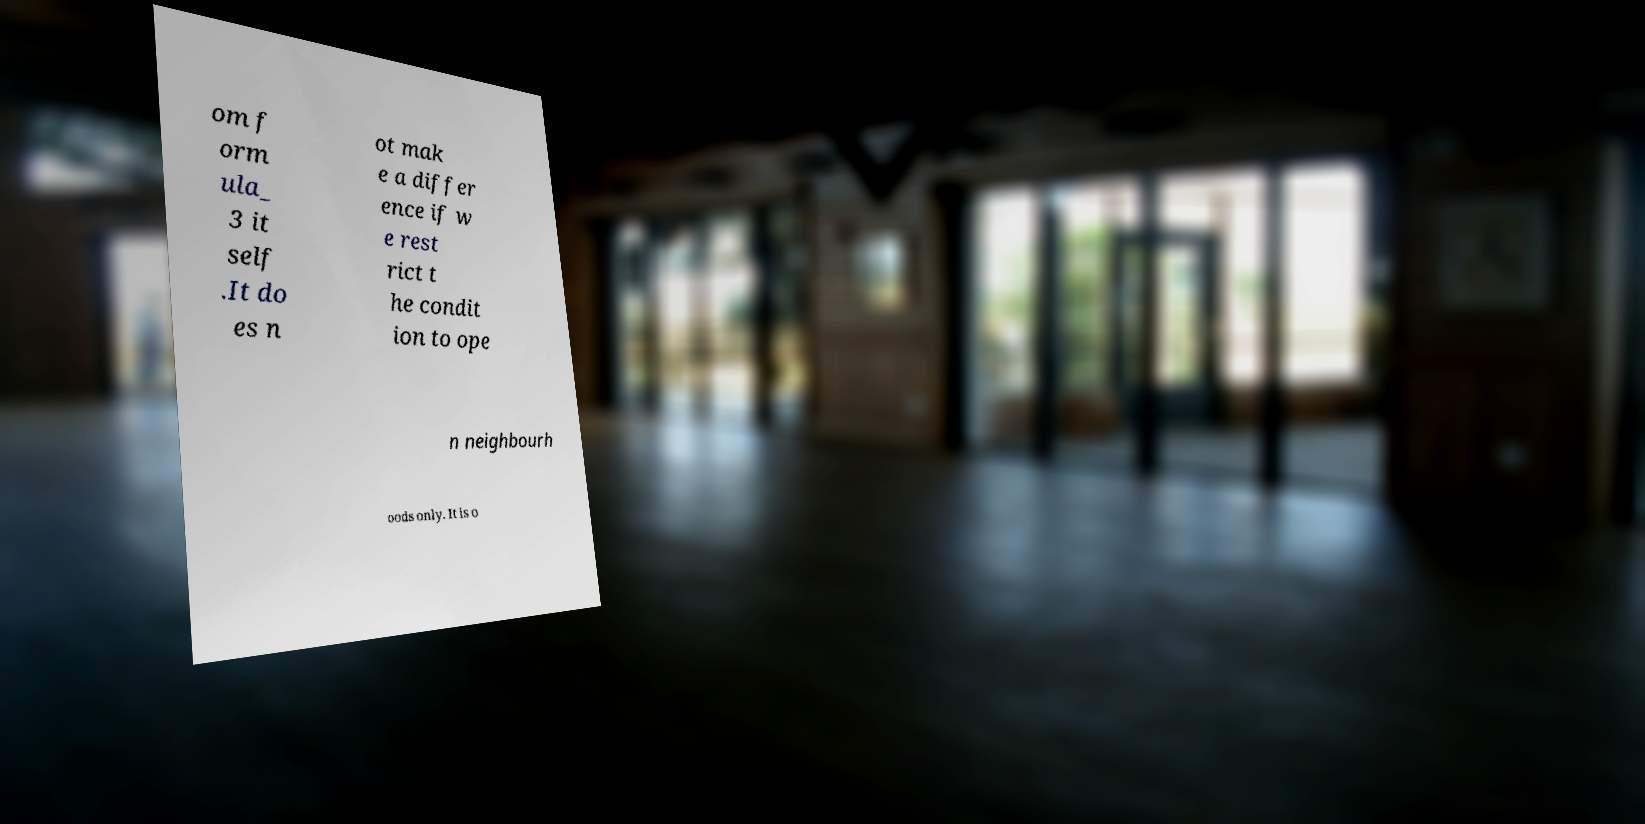Please read and relay the text visible in this image. What does it say? om f orm ula_ 3 it self .It do es n ot mak e a differ ence if w e rest rict t he condit ion to ope n neighbourh oods only. It is o 